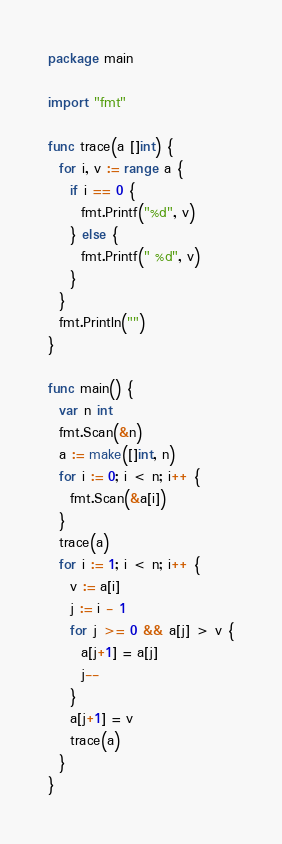Convert code to text. <code><loc_0><loc_0><loc_500><loc_500><_Go_>package main

import "fmt"

func trace(a []int) {
  for i, v := range a {
    if i == 0 {
      fmt.Printf("%d", v)
    } else {
      fmt.Printf(" %d", v)
    }
  }
  fmt.Println("")
}

func main() {
  var n int
  fmt.Scan(&n)
  a := make([]int, n)
  for i := 0; i < n; i++ {
    fmt.Scan(&a[i])
  }
  trace(a)
  for i := 1; i < n; i++ {
    v := a[i]
    j := i - 1
    for j >= 0 && a[j] > v {
      a[j+1] = a[j]
      j--
    }
    a[j+1] = v
    trace(a)
  }
}

</code> 